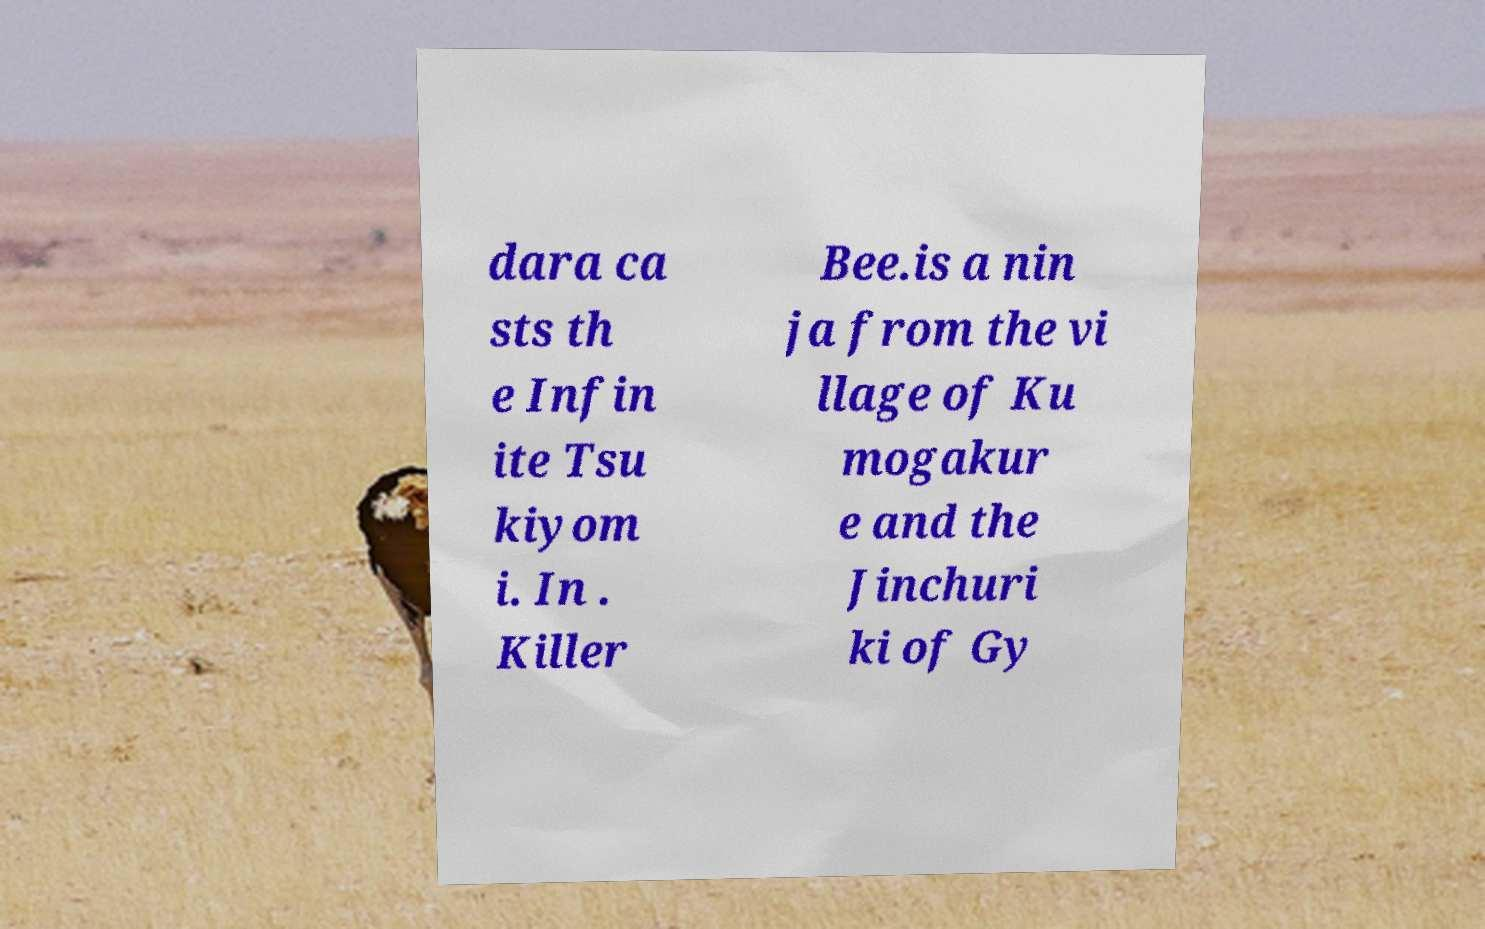Could you extract and type out the text from this image? dara ca sts th e Infin ite Tsu kiyom i. In . Killer Bee.is a nin ja from the vi llage of Ku mogakur e and the Jinchuri ki of Gy 